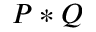Convert formula to latex. <formula><loc_0><loc_0><loc_500><loc_500>P * Q</formula> 